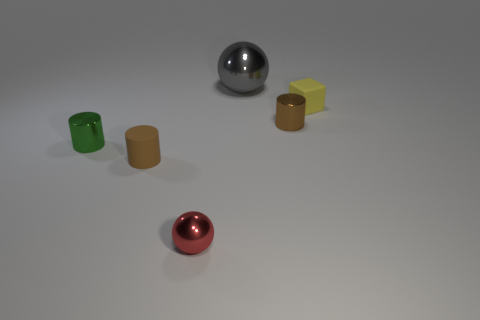There is a tiny metallic thing that is the same color as the tiny rubber cylinder; what is its shape?
Give a very brief answer. Cylinder. Are there any other cylinders of the same color as the matte cylinder?
Offer a terse response. Yes. What is the size of the metal thing that is the same color as the matte cylinder?
Your answer should be compact. Small. Are there any other things that are the same size as the gray shiny sphere?
Provide a short and direct response. No. There is a cylinder that is behind the tiny green metal object; does it have the same color as the matte cylinder?
Your answer should be compact. Yes. Is the large shiny thing the same color as the tiny matte block?
Offer a terse response. No. Are the ball that is left of the large metallic ball and the small brown object on the left side of the gray metallic sphere made of the same material?
Your answer should be very brief. No. There is another cylinder that is the same color as the small matte cylinder; what is its material?
Your response must be concise. Metal. How many brown matte objects are the same shape as the tiny green thing?
Your answer should be very brief. 1. Are the tiny yellow thing and the brown cylinder that is left of the large shiny object made of the same material?
Offer a terse response. Yes. 